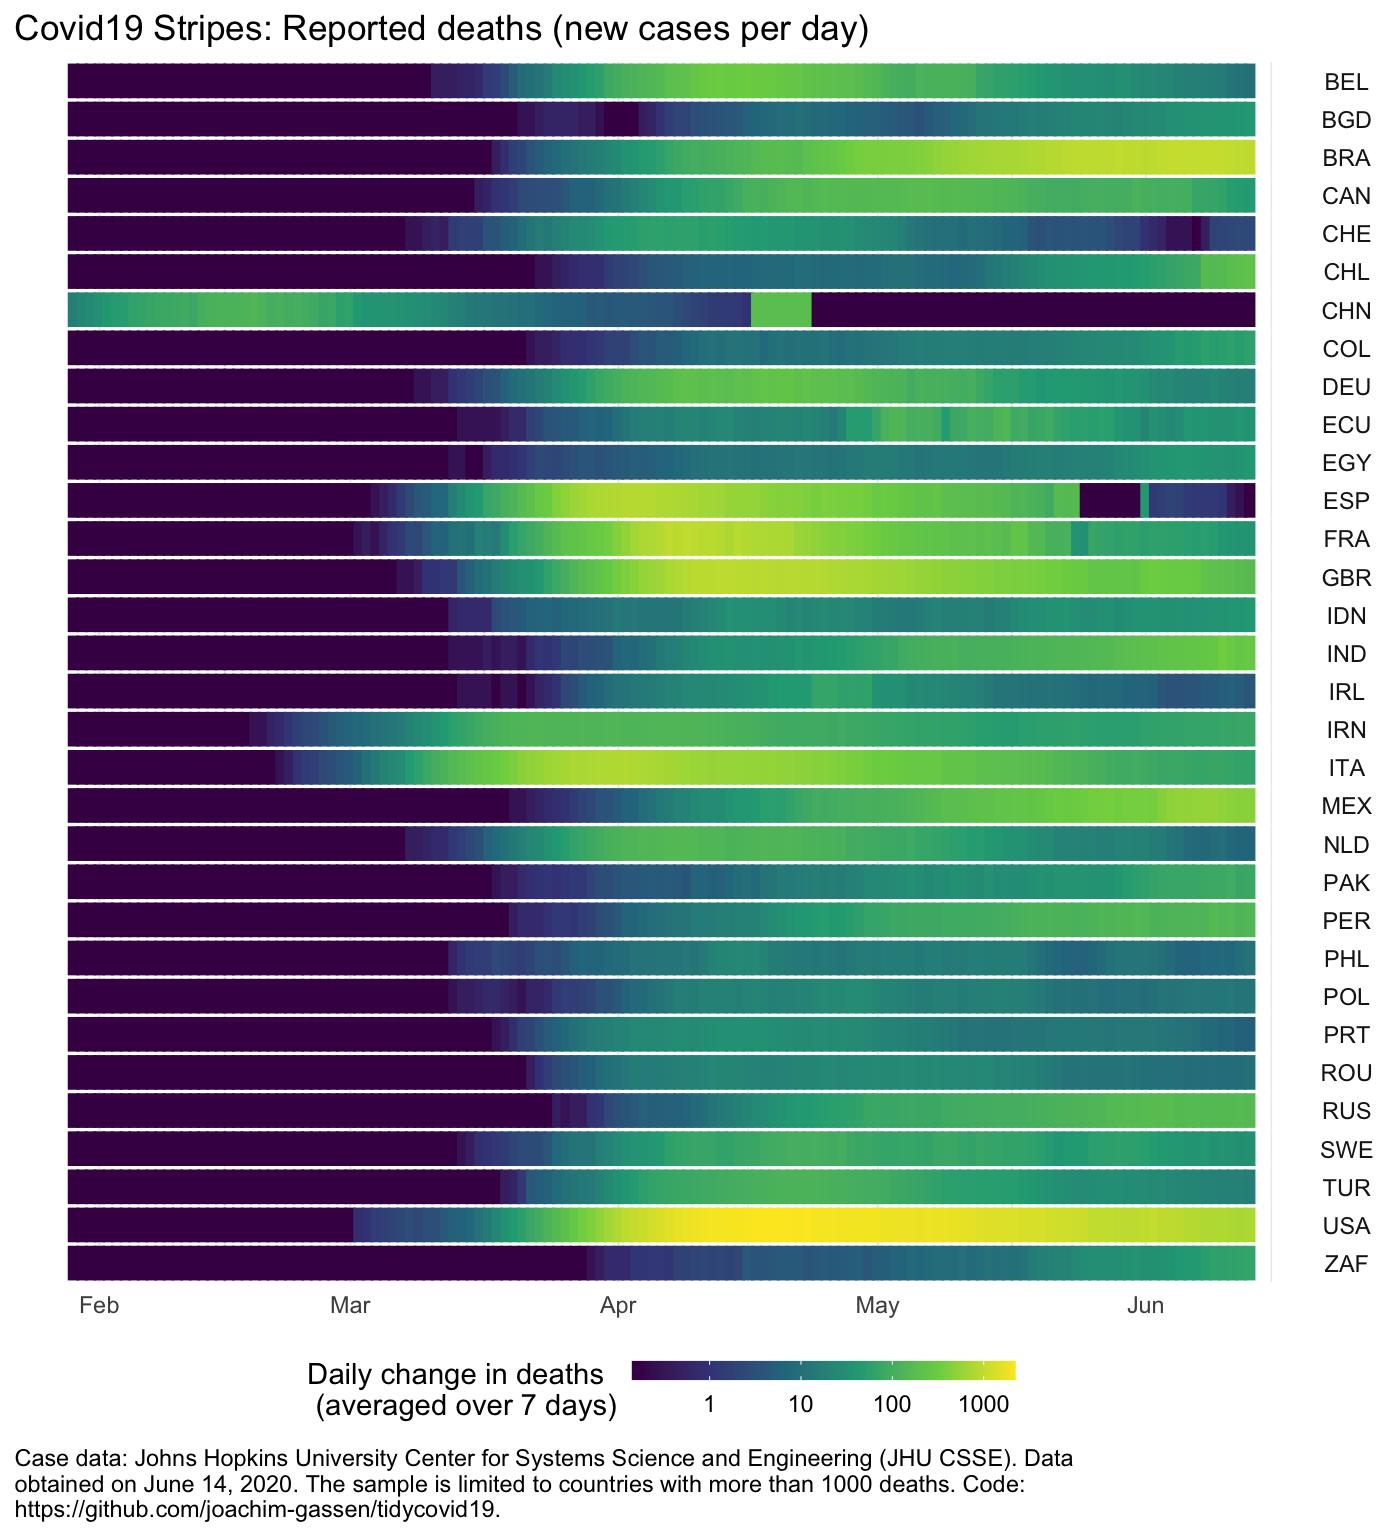Indicate a few pertinent items in this graphic. In February, cases of a specific country exceeded 10. The country in question had a high number of cases. Brazil and Mexico have demonstrated a rising trend in June. After a decline in cases, there was a sudden increase in cases in China in April, followed by a decrease again. The highest number of deaths in the USA occurred between the months of April and May. 